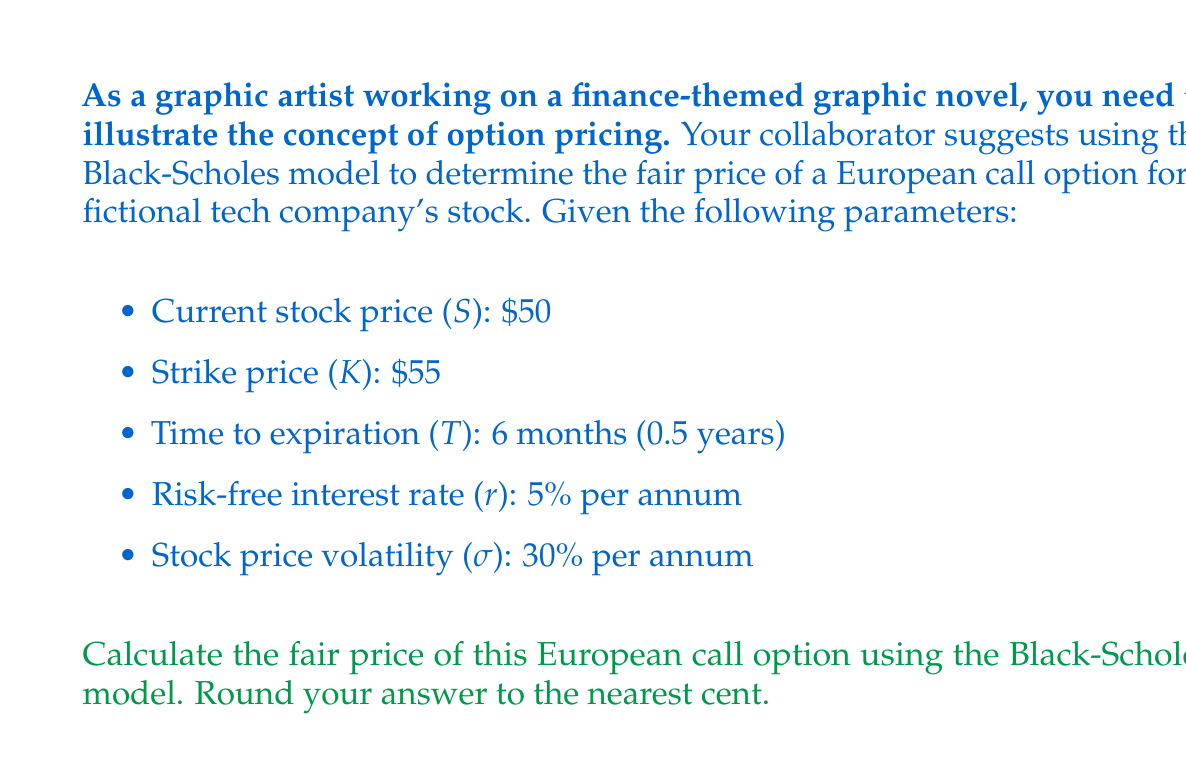What is the answer to this math problem? To solve this problem, we'll use the Black-Scholes formula for pricing European call options:

$$C = SN(d_1) - Ke^{-rT}N(d_2)$$

Where:
$$d_1 = \frac{\ln(S/K) + (r + \sigma^2/2)T}{\sigma\sqrt{T}}$$
$$d_2 = d_1 - \sigma\sqrt{T}$$

And $N(x)$ is the cumulative standard normal distribution function.

Step 1: Calculate $d_1$ and $d_2$

$$d_1 = \frac{\ln(50/55) + (0.05 + 0.3^2/2) * 0.5}{0.3\sqrt{0.5}} = 0.0927$$

$$d_2 = 0.0927 - 0.3\sqrt{0.5} = -0.1193$$

Step 2: Calculate $N(d_1)$ and $N(d_2)$

Using a standard normal distribution table or calculator:

$N(d_1) = N(0.0927) = 0.5369$
$N(d_2) = N(-0.1193) = 0.4525$

Step 3: Apply the Black-Scholes formula

$$C = 50 * 0.5369 - 55 * e^{-0.05 * 0.5} * 0.4525$$

$$C = 26.845 - 24.3382 = 2.5068$$

Step 4: Round to the nearest cent

$C = $2.51$
Answer: $2.51 